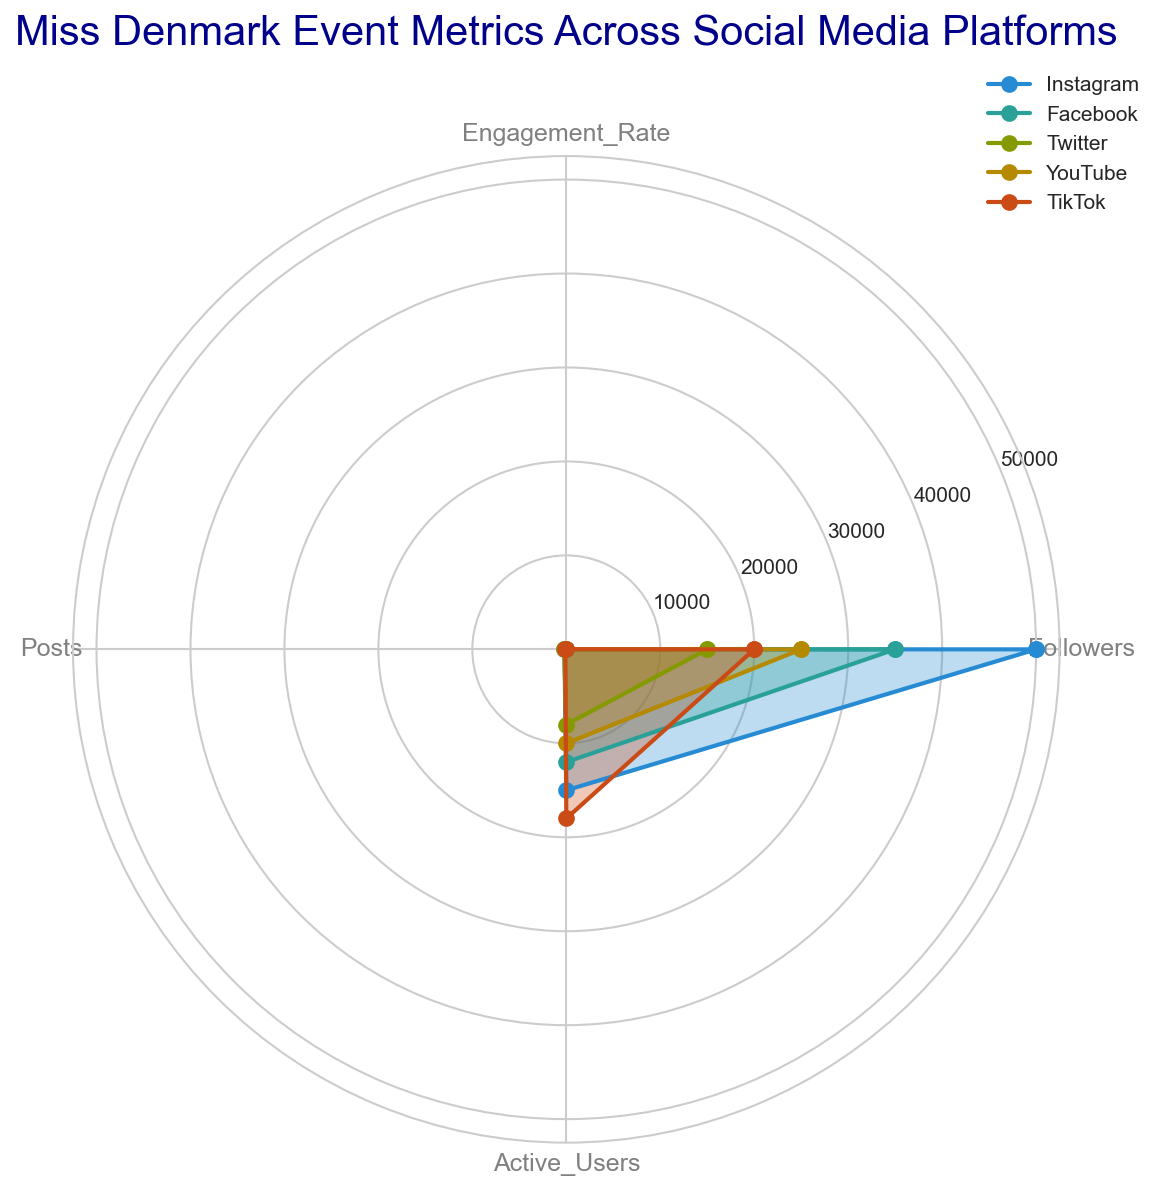Which platform has the highest engagement rate? By observing the radar chart, the platform with the highest value on the "Engagement_Rate" axis can be identified. TikTok has the highest value reaching 9.5%.
Answer: TikTok Which platform has the lowest number of posts? On the "Posts" axis, identify which platform has the shortest line. The shortest line corresponds to TikTok, with 100 posts.
Answer: TikTok What is the difference in follower count between Instagram and Twitter? Subtract the follower count of Twitter from Instagram: Instagram (50,000) - Twitter (15,000) = 35,000.
Answer: 35,000 Among Instagram, Facebook, and YouTube, which has the highest active user count? Examine the radar chart's "Active_Users" axis for Instagram, Facebook, and YouTube. YouTube's value is 10,000, which is the highest among the three.
Answer: YouTube Which platform has the closest number of posts to Facebook? On the "Posts" axis, compare the value for Facebook with other platforms. Facebook has 180 posts, YouTube with 140 posts is the closest.
Answer: YouTube What is the average engagement rate across all platforms? Sum all the engagement rates and divide by the number of platforms: (5.6 + 4.2 + 3.8 + 6.0 + 9.5) / 5 = 5.82.
Answer: 5.82 Compare Instagram and TikTok in terms of active users and followers. Which has a higher value for each metric? For "Active_Users," TikTok has 18,000 and Instagram has 15,000, so TikTok is higher. For "Followers," Instagram has 50,000, while TikTok has 20,000, so Instagram is higher.
Answer: Active_Users: TikTok, Followers: Instagram Which platform's values form the smallest enclosed area in the radar chart? Visually inspect which platform has the smallest overall coverage within the radar chart. Twitter's values collectively form the smallest enclosed area.
Answer: Twitter If platforms are ranked by engagement rate and engagement rate alone, which position does YouTube occupy? Rank the platforms by their engagement rates: TikTok (9.5), YouTube (6.0), Instagram (5.6), Facebook (4.2), Twitter (3.8). YouTube is in 2nd position.
Answer: 2nd How do the number of active users on Facebook and YouTube compare? Reviewing the "Active_Users" axis, Facebook has 12,000 users while YouTube has 10,000 users. Facebook has more users than YouTube.
Answer: Facebook has more active users 